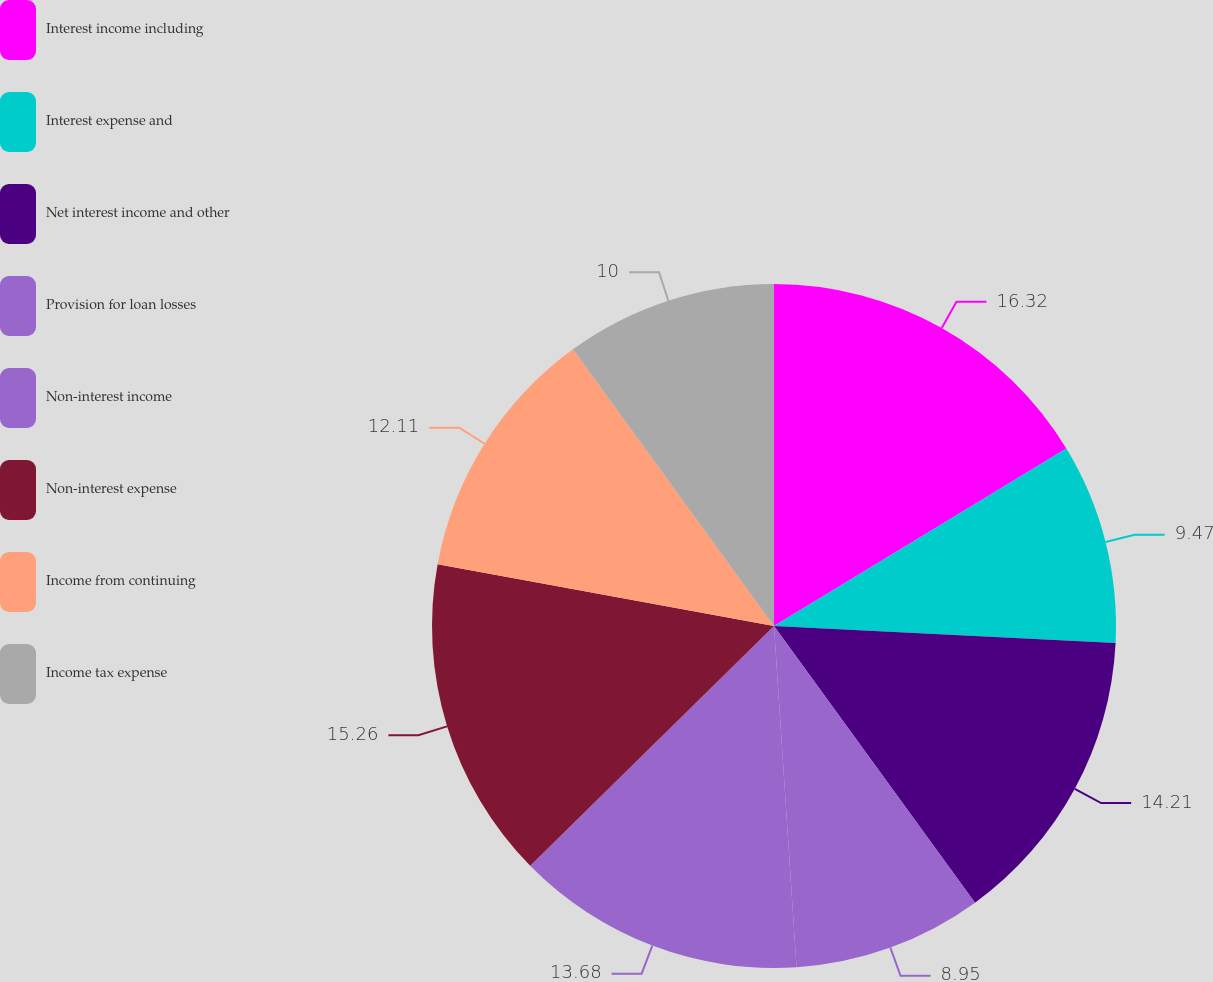Convert chart. <chart><loc_0><loc_0><loc_500><loc_500><pie_chart><fcel>Interest income including<fcel>Interest expense and<fcel>Net interest income and other<fcel>Provision for loan losses<fcel>Non-interest income<fcel>Non-interest expense<fcel>Income from continuing<fcel>Income tax expense<nl><fcel>16.32%<fcel>9.47%<fcel>14.21%<fcel>8.95%<fcel>13.68%<fcel>15.26%<fcel>12.11%<fcel>10.0%<nl></chart> 